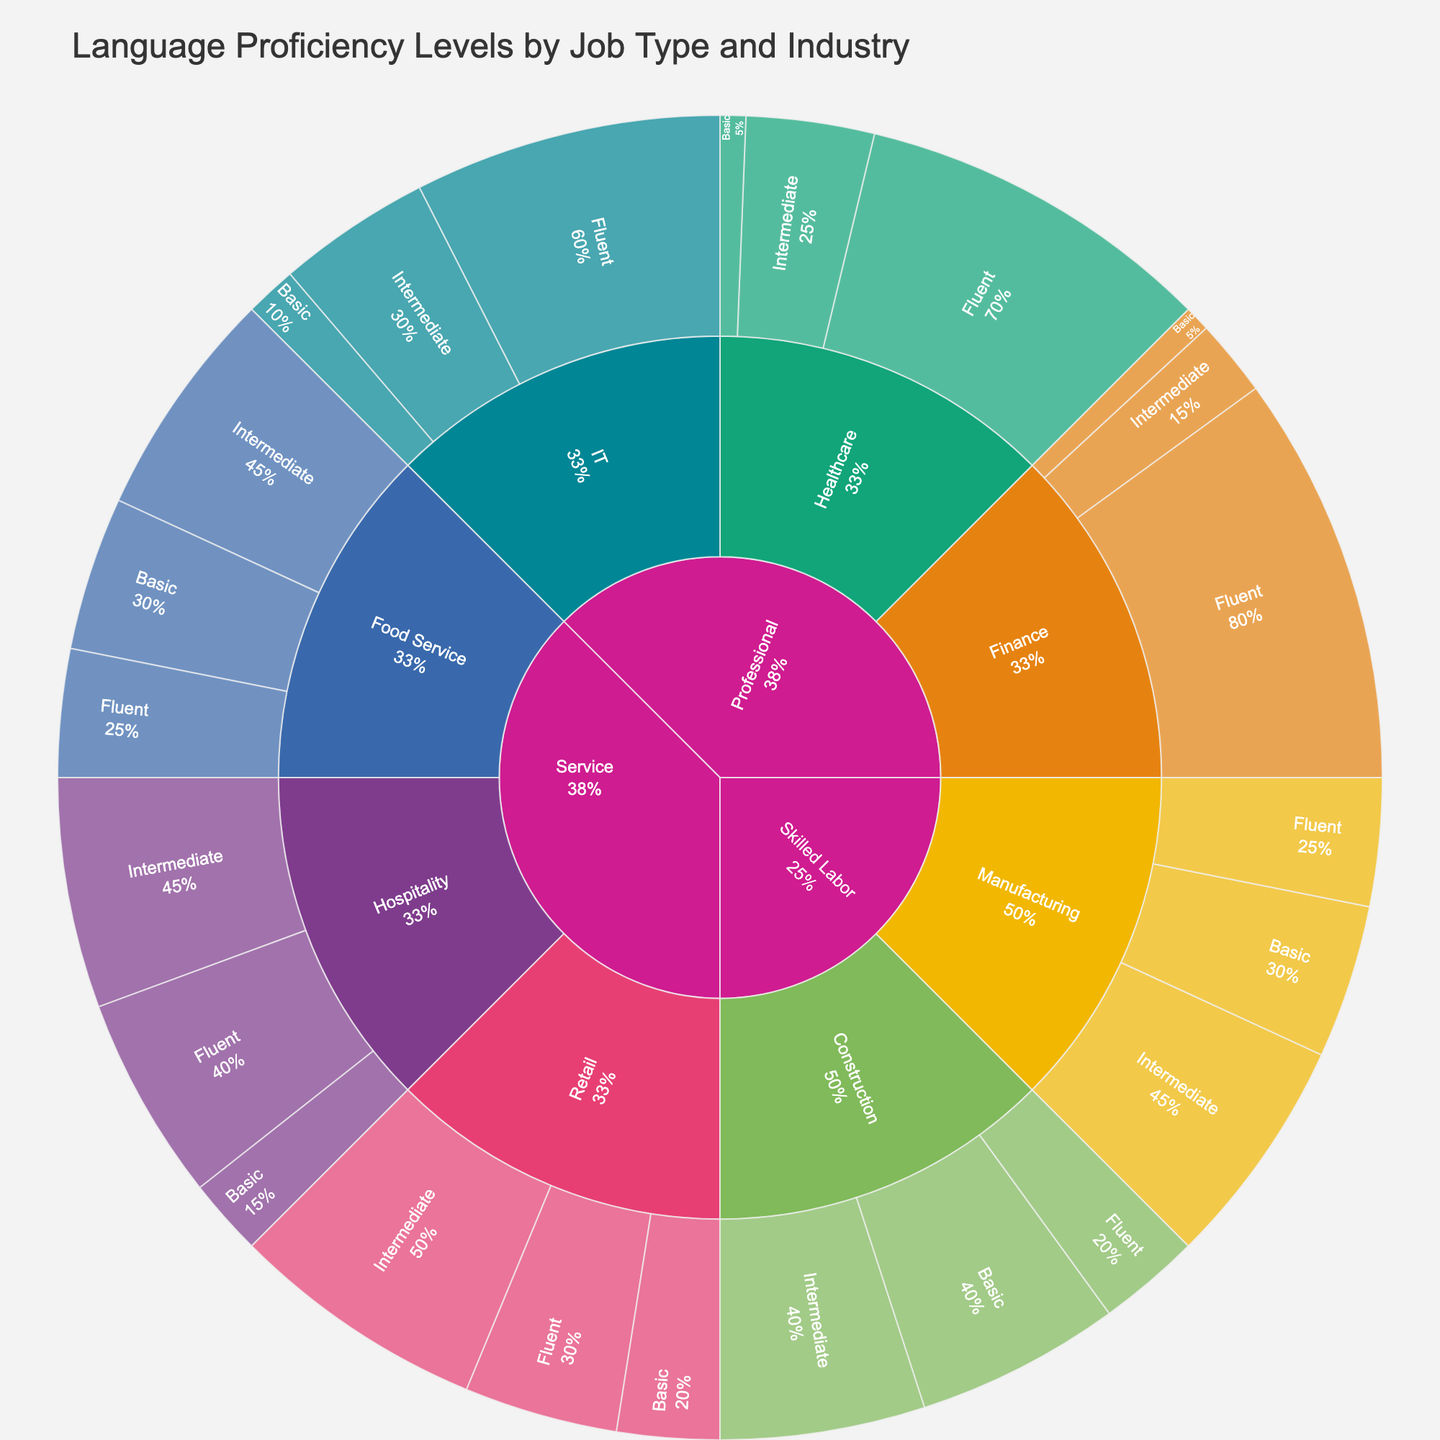What is the title of the sunburst plot? The title of the sunburst plot can be found at the top center of the chart. The text here typically outlines what the data visualization is about.
Answer: Language Proficiency Levels by Job Type and Industry Which industry under the "Professional" job type requires the highest percentage of Fluent proficiency? Look under the "Professional" job type, then identify and compare the Fluent proficiency levels across all indicated industries.
Answer: Finance Which job type has the highest percentage of Intermediate proficiency in the Retail industry? Identify the job types that include the Retail industry, then look specifically at the percentages for Intermediate proficiency levels within those job types.
Answer: Service How does the requirement for Fluent proficiency in IT compare to that in Healthcare? Compare the percentage values listed under Fluent proficiency for both the IT and Healthcare industries.
Answer: IT is lower What is the combined percentage of Intermediate proficiency required in the Food Service and Manufacturing industries? Find the Intermediate proficiency levels for both Food Service and Manufacturing, then sum these percentages together. Food Service Intermediate: 45%, Manufacturing Intermediate: 45%. Combined: 45 + 45.
Answer: 90% Which Industry in the Skilled Labor job type has an equal percentage requirement for Intermediate and Basic proficiency levels? Within the "Skilled Labor" job type, identify the industry where the percentages for Intermediate and Basic levels are the same.
Answer: Construction What percentage of Basic proficiency is required for Service job functions in Retail and Food Service combined? Find the Basic proficiency percentages for Retail and Food Service in the Service job type, then add them up. Retail Basic: 20%, Food Service Basic: 30%. Combined: 20 + 30.
Answer: 50% Which job type and industry combination has the least requirement for Fluent proficiency? Look for the smallest percentage value under Fluent proficiency across all job type and industry combinations.
Answer: Service, Food Service In which industry and job type is the lowest percentage of Basic proficiency observed? Identify the lowest percentage value listed under Basic proficiency, then note the corresponding job type and industry.
Answer: Professional, Healthcare 